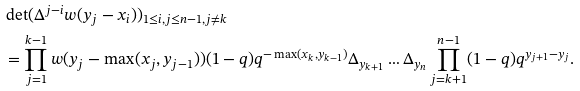<formula> <loc_0><loc_0><loc_500><loc_500>& \det ( \Delta ^ { j - i } w ( y _ { j } - x _ { i } ) ) _ { 1 \leq i , j \leq n - 1 , j \neq k } \\ & = \prod _ { j = 1 } ^ { k - 1 } w ( y _ { j } - \max ( x _ { j } , y _ { j - 1 } ) ) ( 1 - q ) q ^ { - \max ( x _ { k } , y _ { k - 1 } ) } \Delta _ { y _ { k + 1 } } \dots \Delta _ { y _ { n } } \prod _ { j = k + 1 } ^ { n - 1 } ( 1 - q ) q ^ { y _ { j + 1 } - y _ { j } } .</formula> 